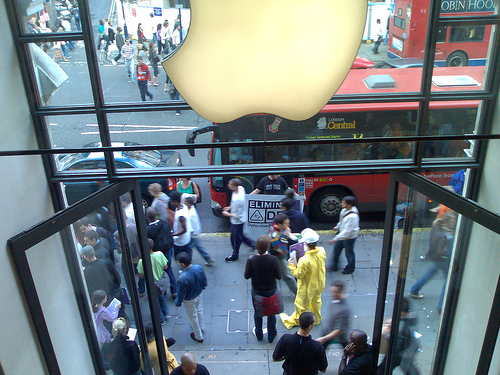<image>
Is there a bus on the sidewalk? No. The bus is not positioned on the sidewalk. They may be near each other, but the bus is not supported by or resting on top of the sidewalk. Is the bus in front of the building? Yes. The bus is positioned in front of the building, appearing closer to the camera viewpoint. 